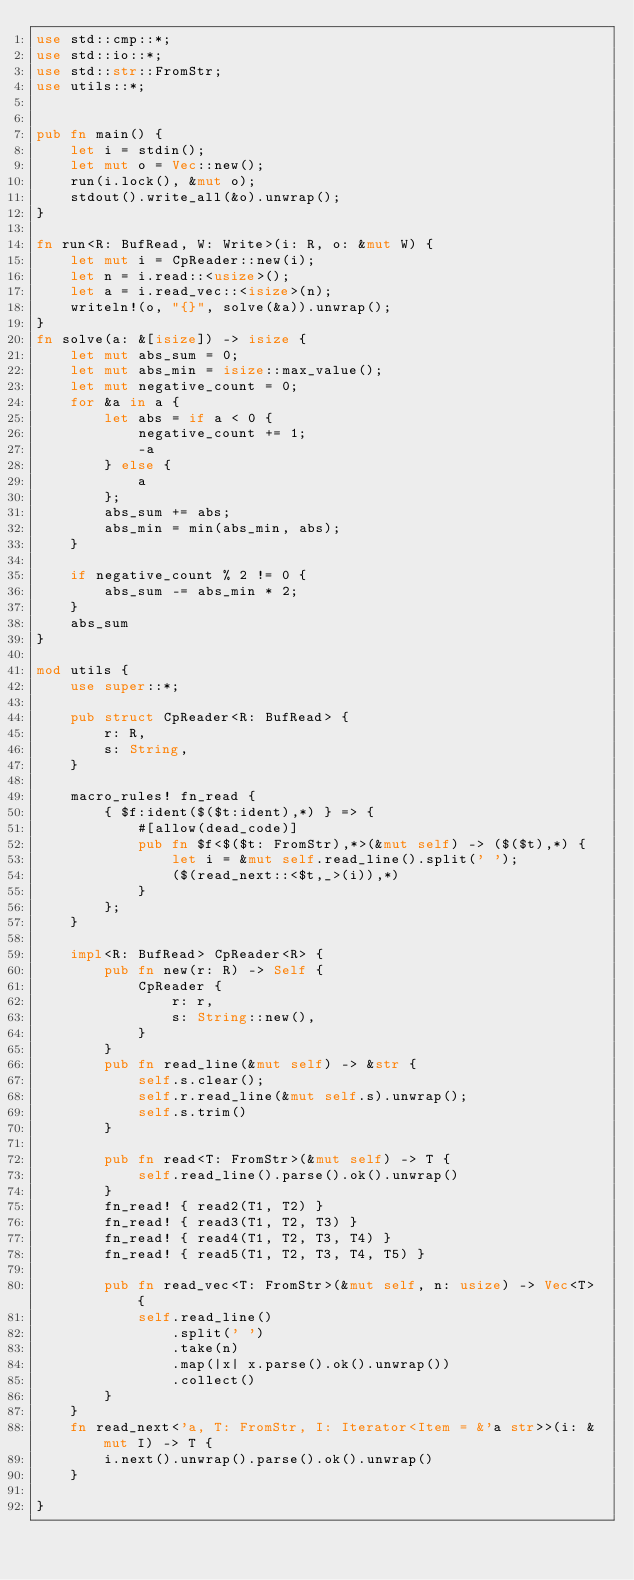<code> <loc_0><loc_0><loc_500><loc_500><_Rust_>use std::cmp::*;
use std::io::*;
use std::str::FromStr;
use utils::*;


pub fn main() {
    let i = stdin();
    let mut o = Vec::new();
    run(i.lock(), &mut o);
    stdout().write_all(&o).unwrap();
}

fn run<R: BufRead, W: Write>(i: R, o: &mut W) {
    let mut i = CpReader::new(i);
    let n = i.read::<usize>();
    let a = i.read_vec::<isize>(n);
    writeln!(o, "{}", solve(&a)).unwrap();
}
fn solve(a: &[isize]) -> isize {
    let mut abs_sum = 0;
    let mut abs_min = isize::max_value();
    let mut negative_count = 0;
    for &a in a {
        let abs = if a < 0 {
            negative_count += 1;
            -a
        } else {
            a
        };
        abs_sum += abs;
        abs_min = min(abs_min, abs);
    }

    if negative_count % 2 != 0 {
        abs_sum -= abs_min * 2;
    }
    abs_sum
}

mod utils {
    use super::*;

    pub struct CpReader<R: BufRead> {
        r: R,
        s: String,
    }

    macro_rules! fn_read {
        { $f:ident($($t:ident),*) } => {
            #[allow(dead_code)]
            pub fn $f<$($t: FromStr),*>(&mut self) -> ($($t),*) {
                let i = &mut self.read_line().split(' ');
                ($(read_next::<$t,_>(i)),*)
            }
        };
    }

    impl<R: BufRead> CpReader<R> {
        pub fn new(r: R) -> Self {
            CpReader {
                r: r,
                s: String::new(),
            }
        }
        pub fn read_line(&mut self) -> &str {
            self.s.clear();
            self.r.read_line(&mut self.s).unwrap();
            self.s.trim()
        }

        pub fn read<T: FromStr>(&mut self) -> T {
            self.read_line().parse().ok().unwrap()
        }
        fn_read! { read2(T1, T2) }
        fn_read! { read3(T1, T2, T3) }
        fn_read! { read4(T1, T2, T3, T4) }
        fn_read! { read5(T1, T2, T3, T4, T5) }

        pub fn read_vec<T: FromStr>(&mut self, n: usize) -> Vec<T> {
            self.read_line()
                .split(' ')
                .take(n)
                .map(|x| x.parse().ok().unwrap())
                .collect()
        }
    }
    fn read_next<'a, T: FromStr, I: Iterator<Item = &'a str>>(i: &mut I) -> T {
        i.next().unwrap().parse().ok().unwrap()
    }

}
</code> 